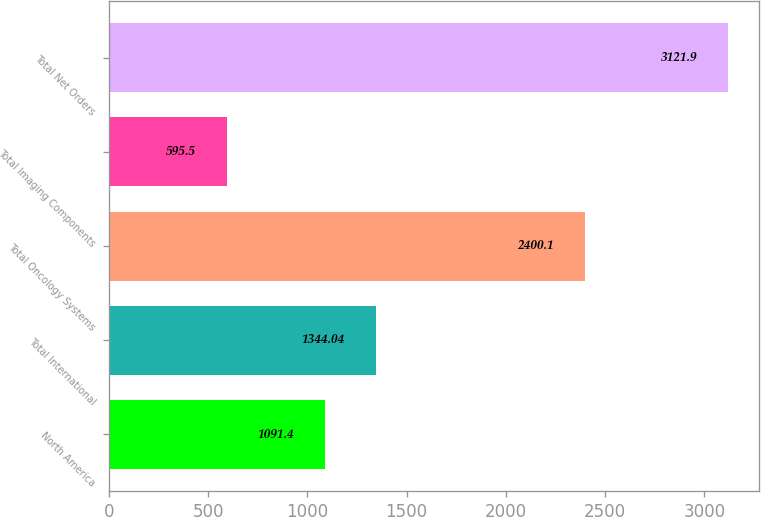Convert chart. <chart><loc_0><loc_0><loc_500><loc_500><bar_chart><fcel>North America<fcel>Total International<fcel>Total Oncology Systems<fcel>Total Imaging Components<fcel>Total Net Orders<nl><fcel>1091.4<fcel>1344.04<fcel>2400.1<fcel>595.5<fcel>3121.9<nl></chart> 